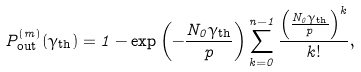<formula> <loc_0><loc_0><loc_500><loc_500>P ^ { ( m ) } _ { \text {out} } ( \gamma _ { \text {th} } ) = 1 - \exp \left ( - \frac { N _ { 0 } \gamma _ { \text {th} } } { p } \right ) \sum ^ { n - 1 } _ { k = 0 } \frac { \left ( \frac { N _ { 0 } \gamma _ { \text {th} } } { p } \right ) ^ { k } } { k ! } ,</formula> 